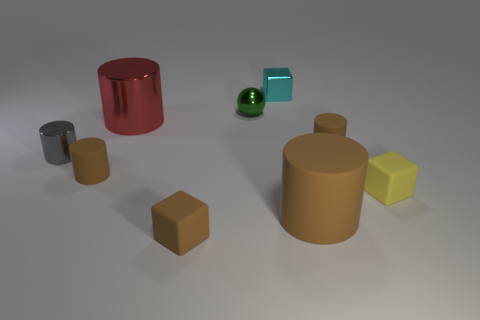Subtract all brown matte cylinders. How many cylinders are left? 2 Subtract all balls. How many objects are left? 8 Subtract all cyan cubes. How many cubes are left? 2 Subtract all red blocks. How many gray balls are left? 0 Subtract 1 brown blocks. How many objects are left? 8 Subtract 1 balls. How many balls are left? 0 Subtract all blue cylinders. Subtract all gray cubes. How many cylinders are left? 5 Subtract all tiny cyan rubber things. Subtract all green shiny balls. How many objects are left? 8 Add 8 tiny yellow objects. How many tiny yellow objects are left? 9 Add 3 small brown cylinders. How many small brown cylinders exist? 5 